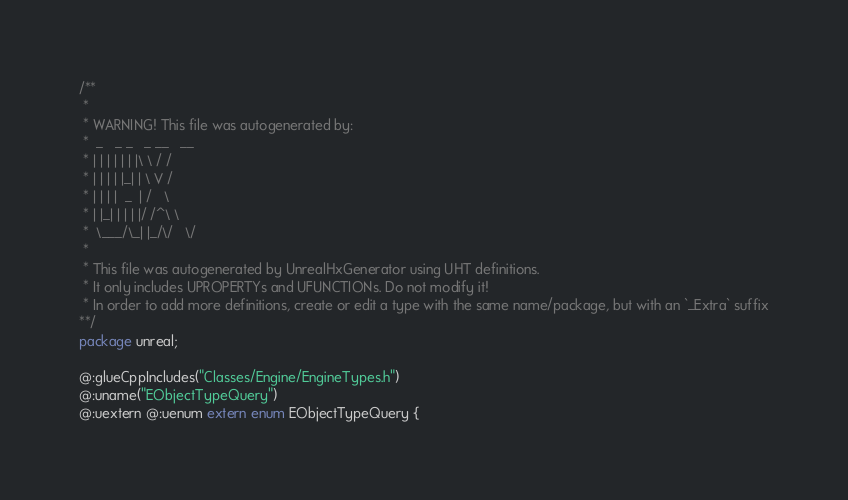<code> <loc_0><loc_0><loc_500><loc_500><_Haxe_>/**
 * 
 * WARNING! This file was autogenerated by: 
 *  _   _ _   _ __   __ 
 * | | | | | | |\ \ / / 
 * | | | | |_| | \ V /  
 * | | | |  _  | /   \  
 * | |_| | | | |/ /^\ \ 
 *  \___/\_| |_/\/   \/ 
 * 
 * This file was autogenerated by UnrealHxGenerator using UHT definitions.
 * It only includes UPROPERTYs and UFUNCTIONs. Do not modify it!
 * In order to add more definitions, create or edit a type with the same name/package, but with an `_Extra` suffix
**/
package unreal;

@:glueCppIncludes("Classes/Engine/EngineTypes.h")
@:uname("EObjectTypeQuery")
@:uextern @:uenum extern enum EObjectTypeQuery {</code> 